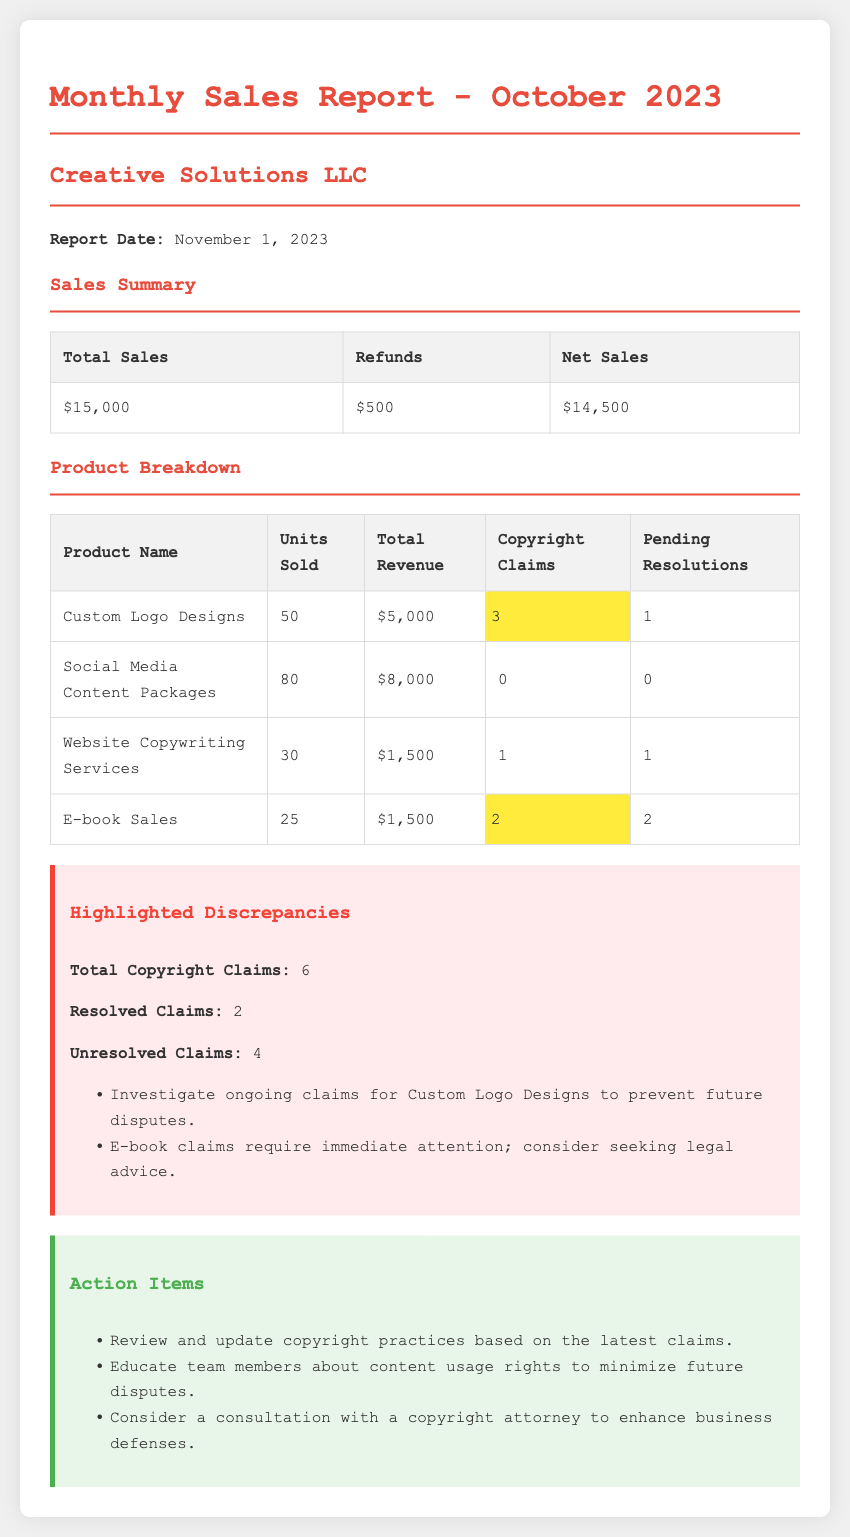what is the total sales for October 2023? The total sales are listed in the sales summary section as $15,000.
Answer: $15,000 how many refunds were processed? The number of refunds is provided in the sales summary, indicating there were $500 in refunds.
Answer: $500 what is the total revenue from Custom Logo Designs? The total revenue for Custom Logo Designs is specified as $5,000 in the product breakdown table.
Answer: $5,000 how many unresolved copyright claims are there? The highlighted discrepancies section states there are 4 unresolved claims.
Answer: 4 what product had the highest units sold? In the product breakdown, Social Media Content Packages had the highest units sold at 80.
Answer: Social Media Content Packages what is the total number of copyright claims across all products? The total copyright claims are summarized in the highlighted discrepancies section, which notes there are 6.
Answer: 6 how many pending resolutions are there for E-book Sales? The product breakdown indicates there are 2 pending resolutions for E-book Sales.
Answer: 2 what action is suggested regarding E-book claims? The action items section suggests to consider seeking legal advice for E-book claims.
Answer: Seek legal advice when was the report date? The report date is mentioned at the beginning of the document as November 1, 2023.
Answer: November 1, 2023 